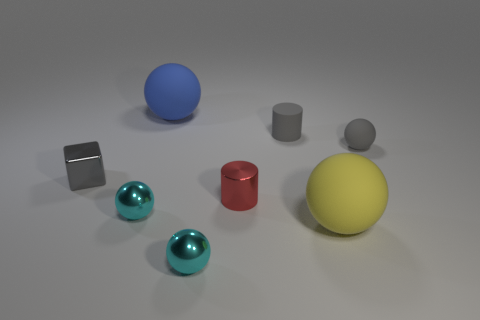Is the cylinder in front of the small gray cube made of the same material as the large blue thing?
Your answer should be compact. No. There is a tiny cylinder behind the gray shiny thing; are there any big balls behind it?
Ensure brevity in your answer.  Yes. There is a yellow thing that is the same shape as the big blue rubber thing; what is its material?
Offer a terse response. Rubber. Is the number of gray things in front of the tiny gray sphere greater than the number of yellow matte things that are left of the tiny gray metallic block?
Your answer should be compact. Yes. What is the shape of the blue object that is the same material as the big yellow ball?
Provide a short and direct response. Sphere. Is the number of cyan spheres right of the blue matte sphere greater than the number of big cyan matte blocks?
Your answer should be compact. Yes. What number of other spheres are the same color as the small rubber ball?
Provide a succinct answer. 0. What number of other objects are the same color as the tiny cube?
Your answer should be very brief. 2. Are there more yellow balls than large red balls?
Ensure brevity in your answer.  Yes. What is the blue thing made of?
Ensure brevity in your answer.  Rubber. 